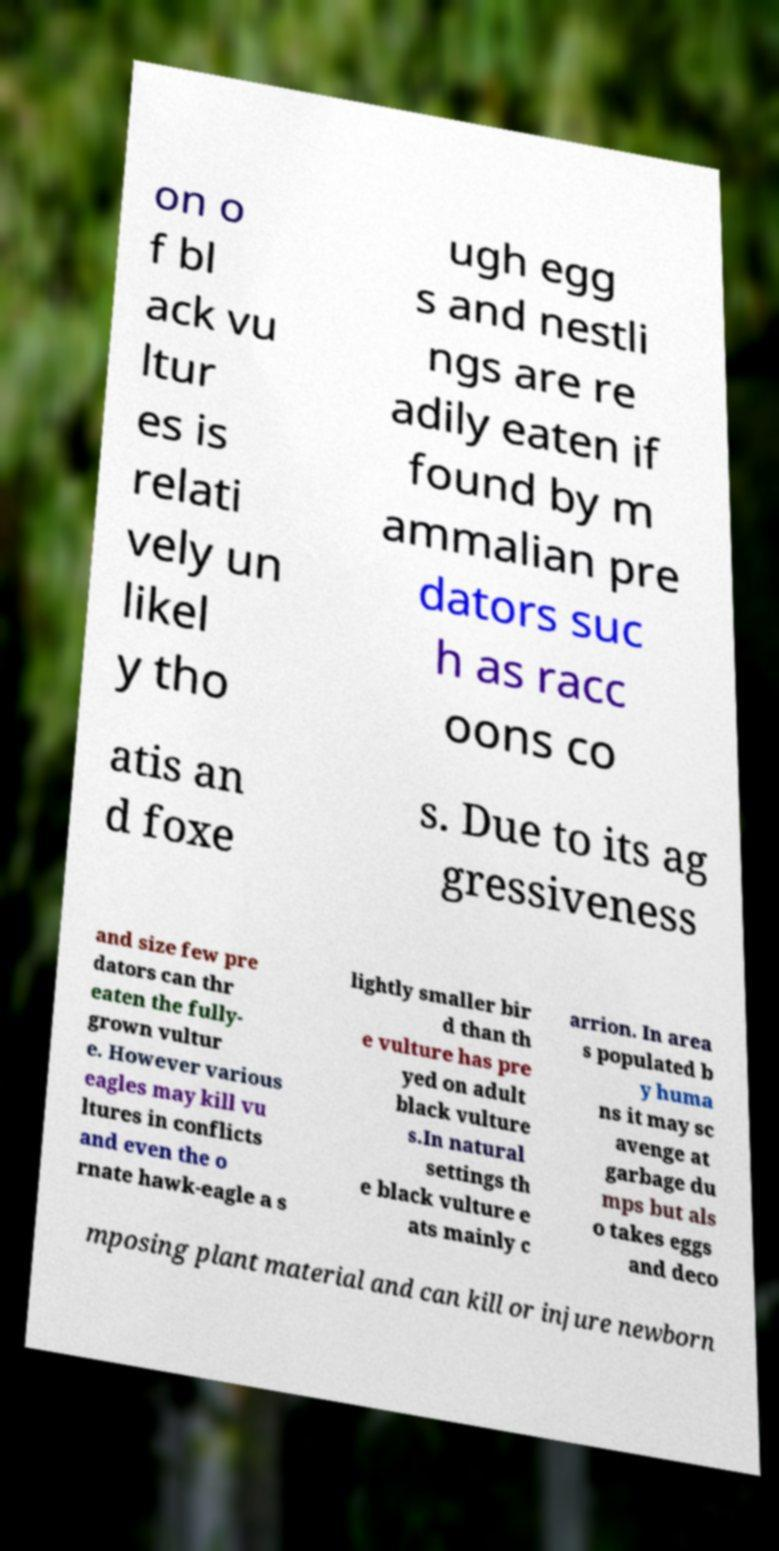Could you extract and type out the text from this image? on o f bl ack vu ltur es is relati vely un likel y tho ugh egg s and nestli ngs are re adily eaten if found by m ammalian pre dators suc h as racc oons co atis an d foxe s. Due to its ag gressiveness and size few pre dators can thr eaten the fully- grown vultur e. However various eagles may kill vu ltures in conflicts and even the o rnate hawk-eagle a s lightly smaller bir d than th e vulture has pre yed on adult black vulture s.In natural settings th e black vulture e ats mainly c arrion. In area s populated b y huma ns it may sc avenge at garbage du mps but als o takes eggs and deco mposing plant material and can kill or injure newborn 